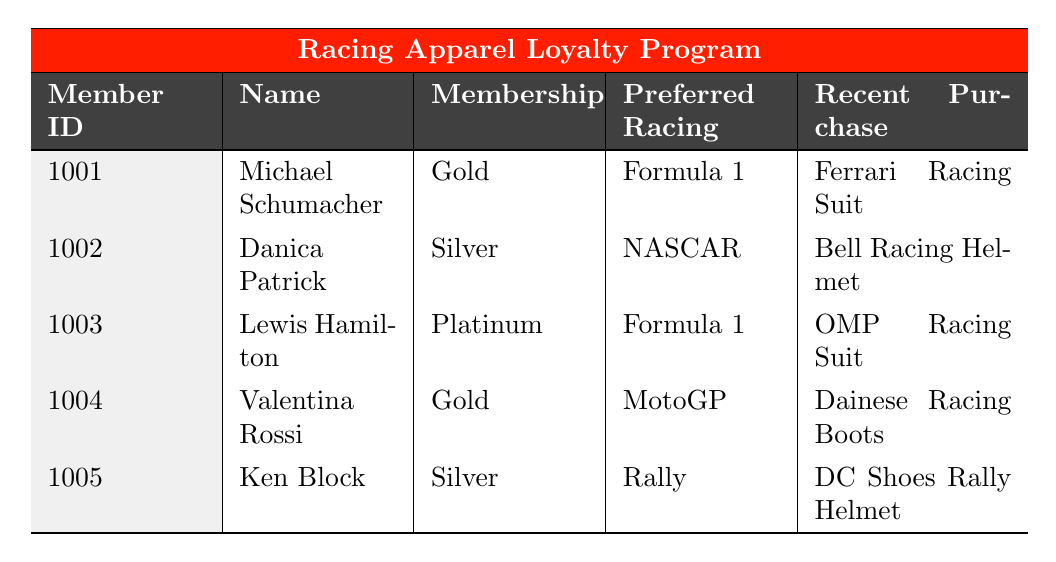What is the membership level of Lewis Hamilton? Lewis Hamilton is listed in the table, and his membership level is specified as "Platinum."
Answer: Platinum How many members in the table prefer Formula 1 racing? By examining the preferred racing type of each member in the table, we can see that both Michael Schumacher and Lewis Hamilton prefer Formula 1 racing, totaling two members.
Answer: 2 Which member made the highest total purchases? The total purchases for each member can be compared, with Lewis Hamilton having the highest total purchases at $5500.00.
Answer: Lewis Hamilton Is Danica Patrick a Gold member? Danica Patrick's membership level is listed as "Silver," which is not the same as "Gold."
Answer: No Which member joined the loyalty program most recently? The join dates of the members are compared, where Ken Block joined on November 30, 2021, making him the most recent member.
Answer: Ken Block What was the total spending of the Gold members? The total purchases for Gold members (Michael Schumacher and Valentina Rossi) are calculated: $3750.50 + $3200.25 = $6950.75.
Answer: $6950.75 How many racing suits are purchased by members overall? Checking the item details from the recent purchases, Michael Schumacher bought 1 Ferrari Racing Suit and Lewis Hamilton bought 1 OMP Racing Suit; together, that totals 2 racing suits.
Answer: 2 Which member has the oldest age? Comparing ages in the data, Lewis Hamilton at age 42 is identified as the oldest member.
Answer: Lewis Hamilton Did any member purchase items in the same month? The purchase dates show that Michael Schumacher made purchases in April and August, while other members made purchases in different months. Thus, no members purchased in the same month.
Answer: No What is the average age of the loyalty members? We calculate the average using the ages provided: (35 + 28 + 42 + 31 + 39) / 5 = 35. The total age sum is 175, and dividing by 5 gives us an average of 35.
Answer: 35 How much did Danica Patrick spend on her recent purchases? Danica Patrick's recent purchase is noted as the Bell Racing Helmet, which costs $800.25, thus her total spend is exactly that amount.
Answer: $800.25 